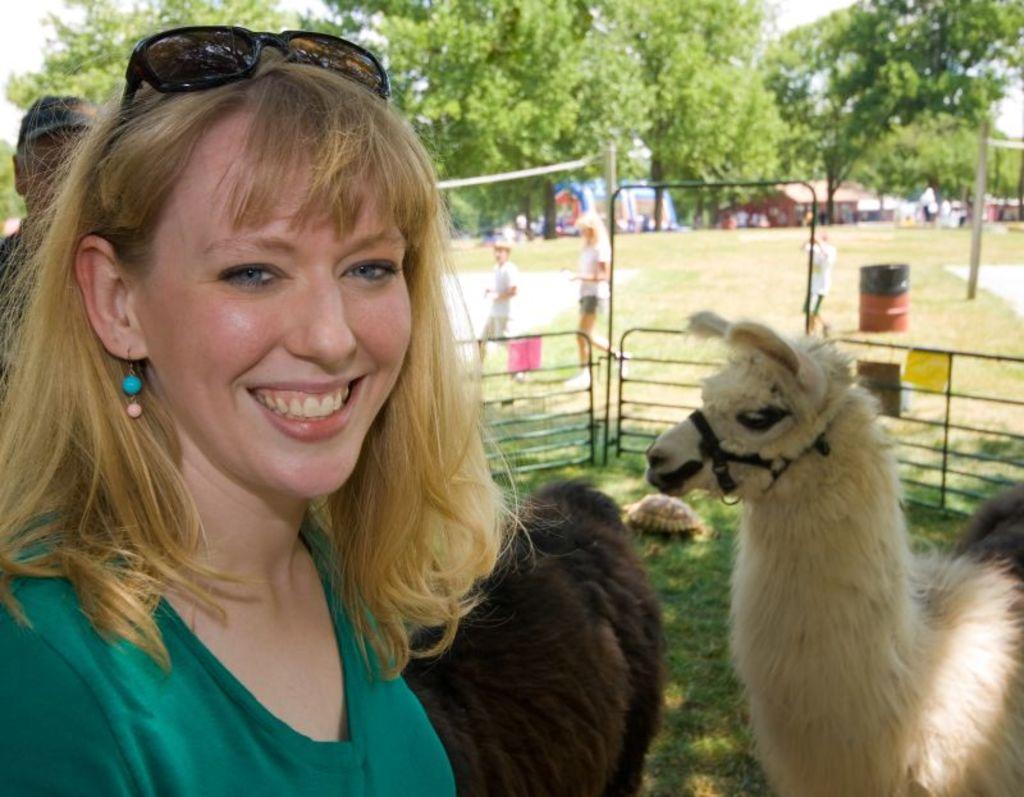Can you describe this image briefly? It is a park there is a woman standing in the front and smiling, behind her there are two animals and in the background some people were moving on the grass , behind them there are many trees. 